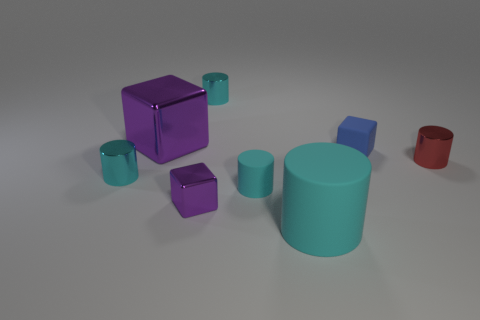Subtract all red spheres. How many cyan cylinders are left? 4 Subtract all red cylinders. How many cylinders are left? 4 Subtract all small matte cylinders. How many cylinders are left? 4 Subtract all purple cylinders. Subtract all brown blocks. How many cylinders are left? 5 Add 1 large cyan cylinders. How many objects exist? 9 Subtract all cylinders. How many objects are left? 3 Add 8 big red rubber spheres. How many big red rubber spheres exist? 8 Subtract 0 purple cylinders. How many objects are left? 8 Subtract all cubes. Subtract all big green things. How many objects are left? 5 Add 7 blue cubes. How many blue cubes are left? 8 